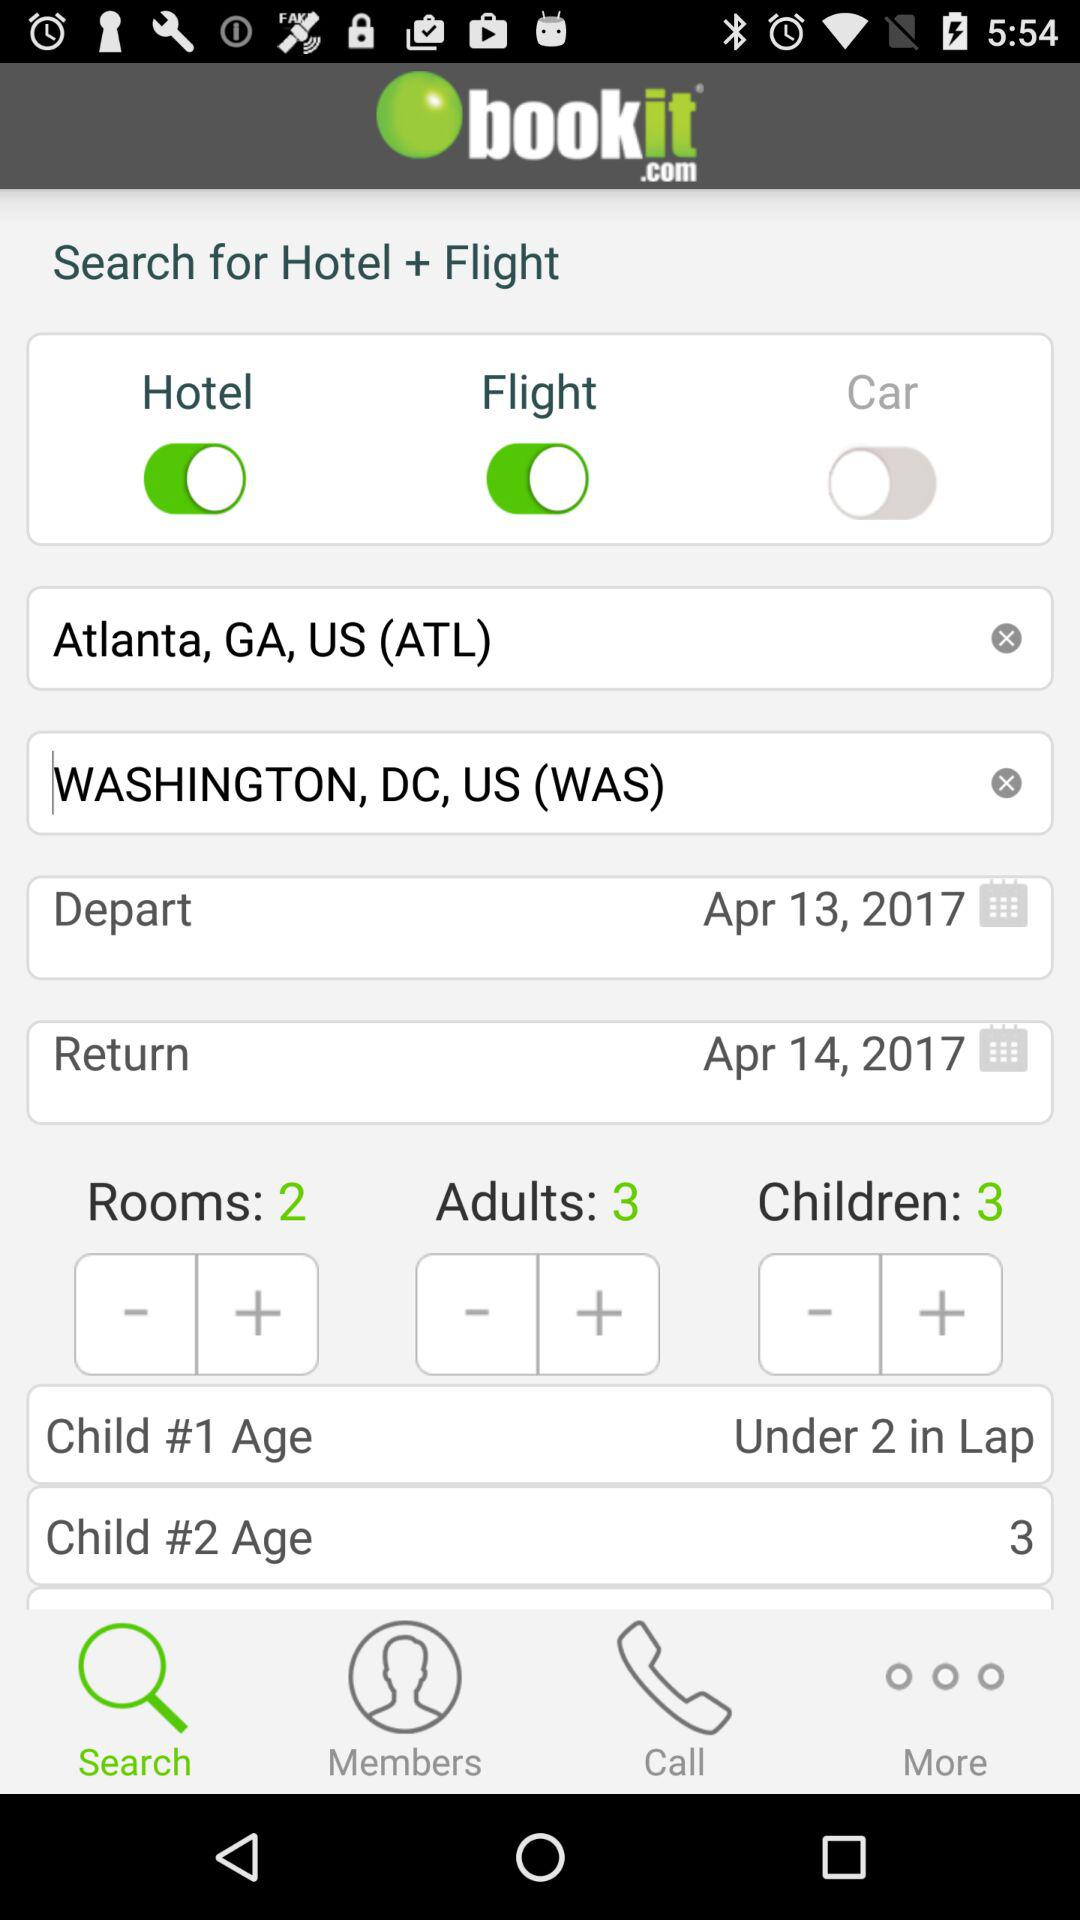What is the status of the "Hotel"? The status of the "Hotel" is "on". 